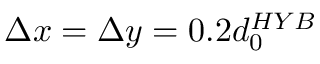Convert formula to latex. <formula><loc_0><loc_0><loc_500><loc_500>\Delta x = \Delta y = 0 . 2 d _ { 0 } ^ { H Y B }</formula> 